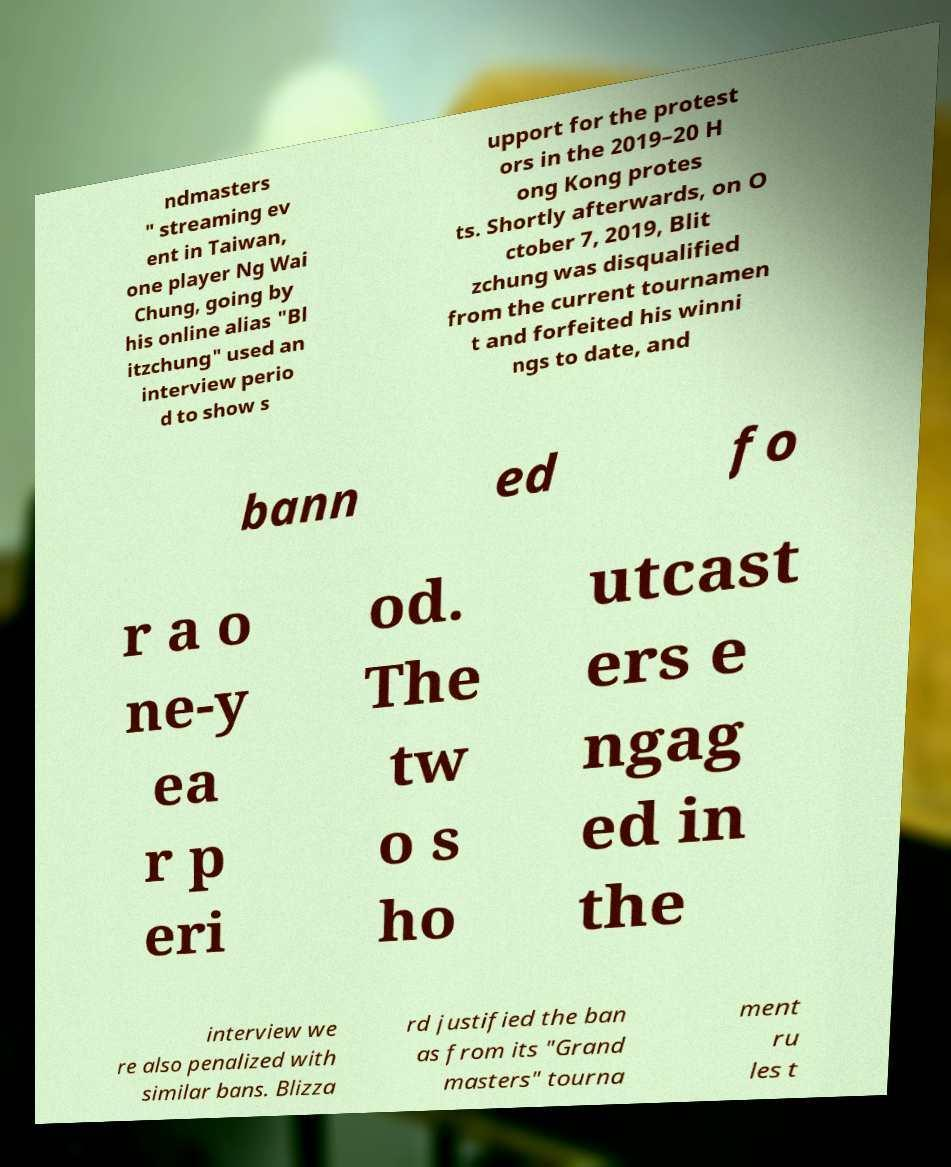Can you accurately transcribe the text from the provided image for me? ndmasters " streaming ev ent in Taiwan, one player Ng Wai Chung, going by his online alias "Bl itzchung" used an interview perio d to show s upport for the protest ors in the 2019–20 H ong Kong protes ts. Shortly afterwards, on O ctober 7, 2019, Blit zchung was disqualified from the current tournamen t and forfeited his winni ngs to date, and bann ed fo r a o ne-y ea r p eri od. The tw o s ho utcast ers e ngag ed in the interview we re also penalized with similar bans. Blizza rd justified the ban as from its "Grand masters" tourna ment ru les t 